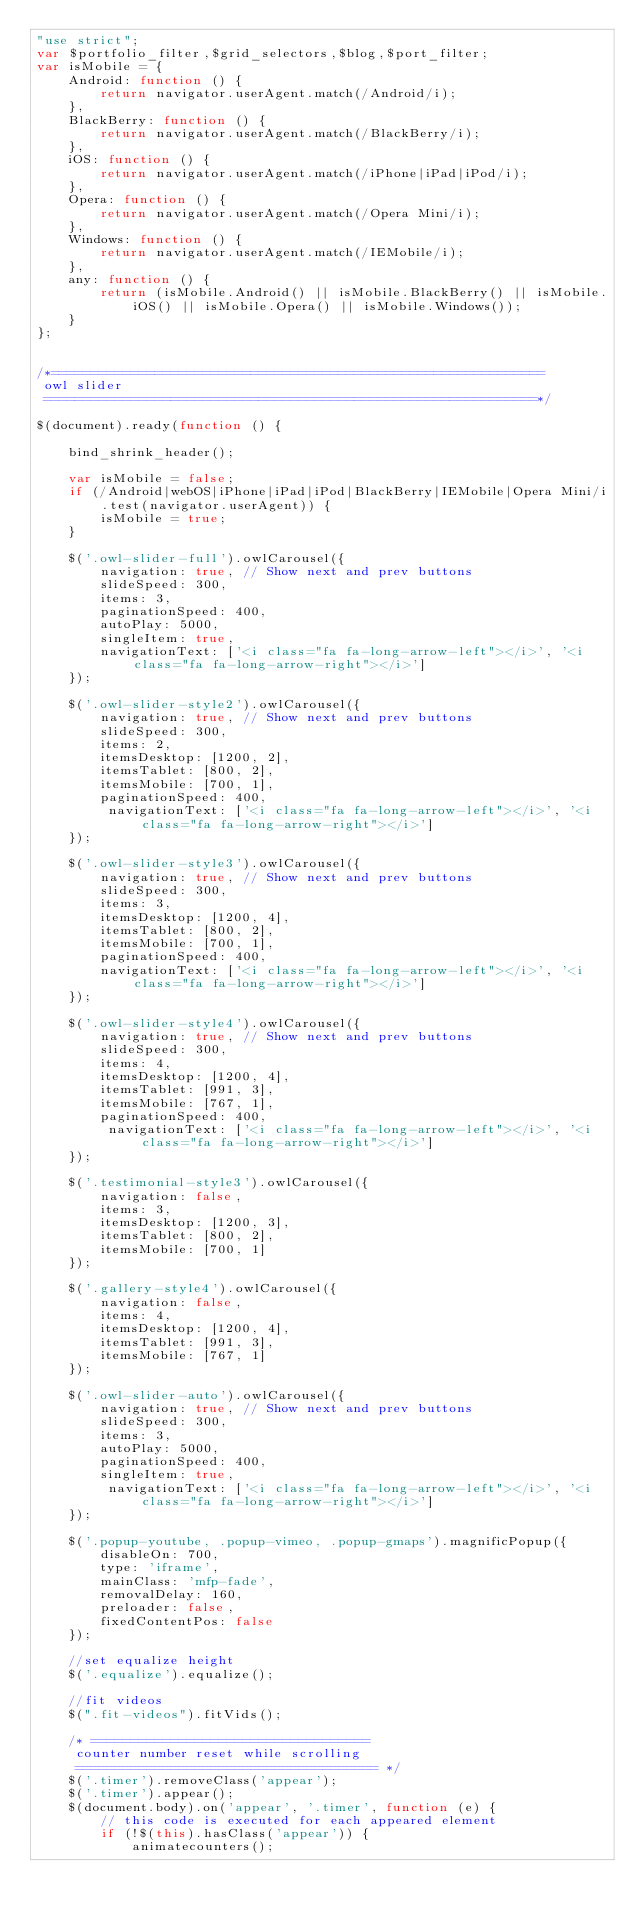<code> <loc_0><loc_0><loc_500><loc_500><_JavaScript_>"use strict";
var $portfolio_filter,$grid_selectors,$blog,$port_filter;
var isMobile = {
    Android: function () {
        return navigator.userAgent.match(/Android/i);
    },
    BlackBerry: function () {
        return navigator.userAgent.match(/BlackBerry/i);
    },
    iOS: function () {
        return navigator.userAgent.match(/iPhone|iPad|iPod/i);
    },
    Opera: function () {
        return navigator.userAgent.match(/Opera Mini/i);
    },
    Windows: function () {
        return navigator.userAgent.match(/IEMobile/i);
    },
    any: function () {
        return (isMobile.Android() || isMobile.BlackBerry() || isMobile.iOS() || isMobile.Opera() || isMobile.Windows());
    }
};


/*==============================================================
 owl slider
 ==============================================================*/

$(document).ready(function () {

    bind_shrink_header();
    
    var isMobile = false;
    if (/Android|webOS|iPhone|iPad|iPod|BlackBerry|IEMobile|Opera Mini/i.test(navigator.userAgent)) {
        isMobile = true;
    }
    
    $('.owl-slider-full').owlCarousel({
        navigation: true, // Show next and prev buttons
        slideSpeed: 300,
        items: 3,
        paginationSpeed: 400,
        autoPlay: 5000,
        singleItem: true,
        navigationText: ['<i class="fa fa-long-arrow-left"></i>', '<i class="fa fa-long-arrow-right"></i>']
    });
    
    $('.owl-slider-style2').owlCarousel({
        navigation: true, // Show next and prev buttons
        slideSpeed: 300,
        items: 2,
        itemsDesktop: [1200, 2],
        itemsTablet: [800, 2],
        itemsMobile: [700, 1],
        paginationSpeed: 400,
         navigationText: ['<i class="fa fa-long-arrow-left"></i>', '<i class="fa fa-long-arrow-right"></i>']
    });

    $('.owl-slider-style3').owlCarousel({
        navigation: true, // Show next and prev buttons
        slideSpeed: 300,
        items: 3,
        itemsDesktop: [1200, 4],
        itemsTablet: [800, 2],
        itemsMobile: [700, 1],
        paginationSpeed: 400,
        navigationText: ['<i class="fa fa-long-arrow-left"></i>', '<i class="fa fa-long-arrow-right"></i>']
    });

    $('.owl-slider-style4').owlCarousel({
        navigation: true, // Show next and prev buttons
        slideSpeed: 300,
        items: 4,
        itemsDesktop: [1200, 4],
        itemsTablet: [991, 3],
        itemsMobile: [767, 1],
        paginationSpeed: 400,
         navigationText: ['<i class="fa fa-long-arrow-left"></i>', '<i class="fa fa-long-arrow-right"></i>']
    });

    $('.testimonial-style3').owlCarousel({
        navigation: false,
        items: 3,
        itemsDesktop: [1200, 3],
        itemsTablet: [800, 2],
        itemsMobile: [700, 1]
    });

    $('.gallery-style4').owlCarousel({
        navigation: false,
        items: 4,
        itemsDesktop: [1200, 4],
        itemsTablet: [991, 3],
        itemsMobile: [767, 1]
    });

    $('.owl-slider-auto').owlCarousel({
        navigation: true, // Show next and prev buttons
        slideSpeed: 300,
        items: 3,
        autoPlay: 5000,
        paginationSpeed: 400,
        singleItem: true,
         navigationText: ['<i class="fa fa-long-arrow-left"></i>', '<i class="fa fa-long-arrow-right"></i>']
    });

    $('.popup-youtube, .popup-vimeo, .popup-gmaps').magnificPopup({
        disableOn: 700,
        type: 'iframe',
        mainClass: 'mfp-fade',
        removalDelay: 160,
        preloader: false,
        fixedContentPos: false
    });

    //set equalize height
    $('.equalize').equalize();

    //fit videos
    $(".fit-videos").fitVids();

    /* ===================================
     counter number reset while scrolling
     ====================================== */
    $('.timer').removeClass('appear');
    $('.timer').appear();
    $(document.body).on('appear', '.timer', function (e) {
        // this code is executed for each appeared element
        if (!$(this).hasClass('appear')) {
            animatecounters();</code> 